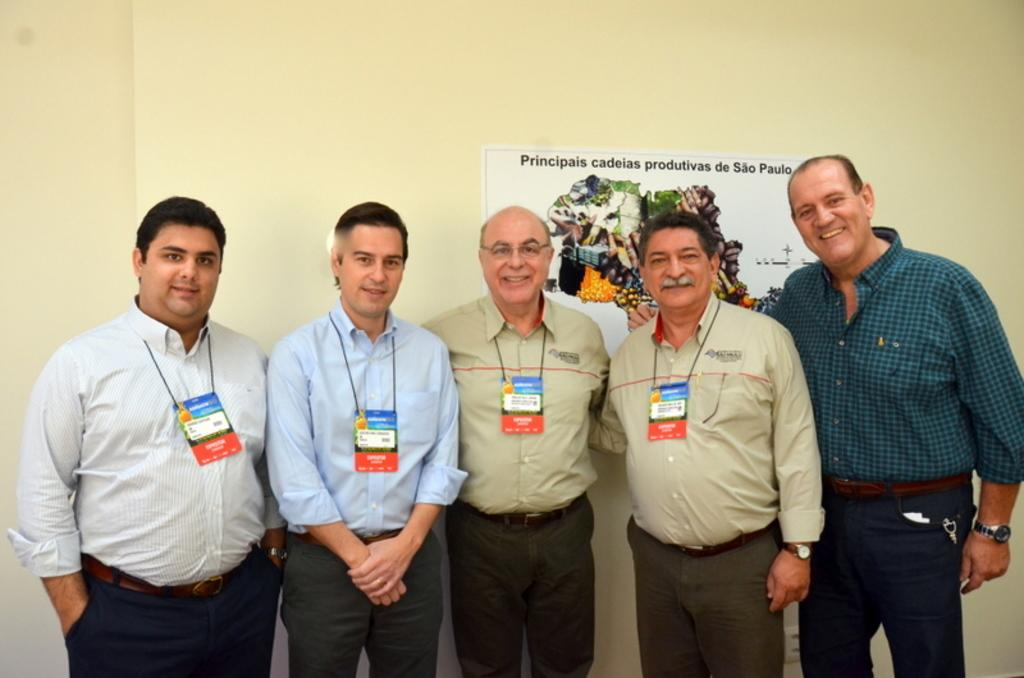What is happening in the image? There are people standing in the image. How are the people in the image feeling? The people are smiling in the image. What can be seen in the background of the image? There is a poster on a wall in the background of the image. What type of sail can be seen in the image? There is no sail present in the image. What kind of hall is visible in the image? There is no hall visible in the image. 